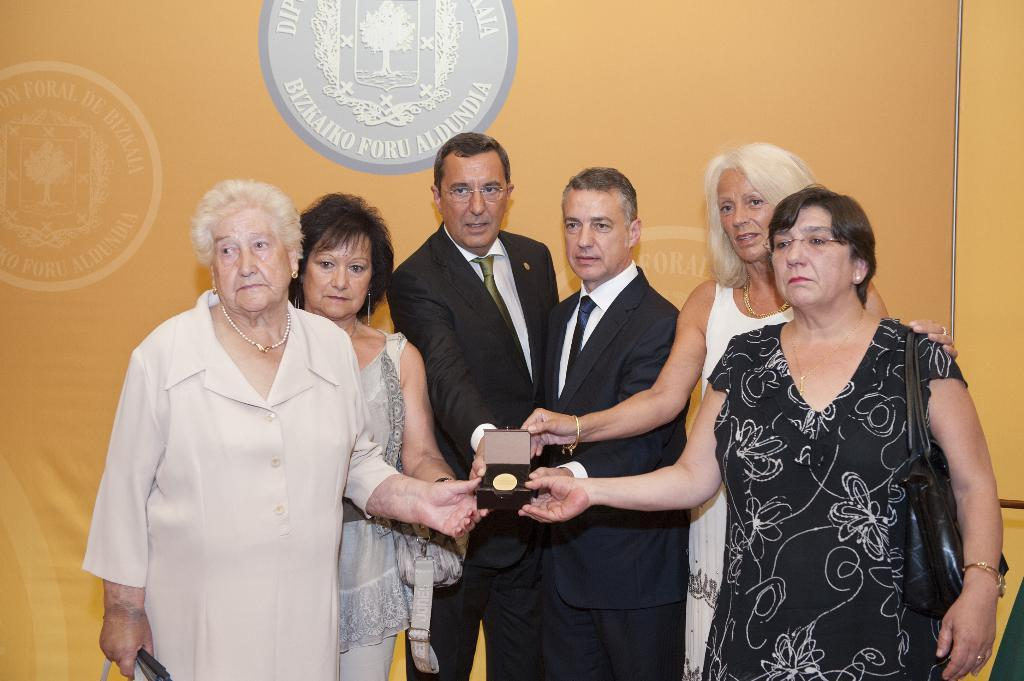What is happening in the image involving a group of people? The group of people is catching a box in the image. What can be seen in the background of the image? The background of the image is orange. Are there any additional features on the wall in the image? Yes, there is a stamp on the wall in the image. What type of carriage is being used by the lawyer in the image? There is no carriage or lawyer present in the image. Can you tell me the shape of the heart in the image? There is no heart present in the image. 